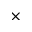<formula> <loc_0><loc_0><loc_500><loc_500>\times</formula> 